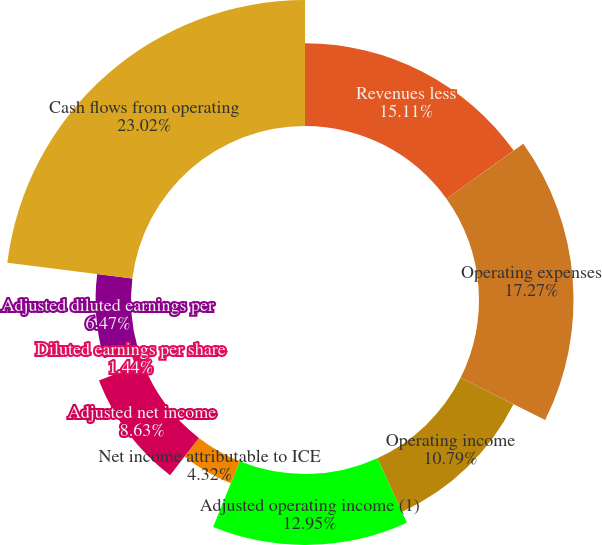Convert chart. <chart><loc_0><loc_0><loc_500><loc_500><pie_chart><fcel>Revenues less<fcel>Operating expenses<fcel>Operating income<fcel>Adjusted operating income (1)<fcel>Net income attributable to ICE<fcel>Adjusted net income<fcel>Diluted earnings per share<fcel>Adjusted diluted earnings per<fcel>Cash flows from operating<nl><fcel>15.11%<fcel>17.27%<fcel>10.79%<fcel>12.95%<fcel>4.32%<fcel>8.63%<fcel>1.44%<fcel>6.47%<fcel>23.02%<nl></chart> 